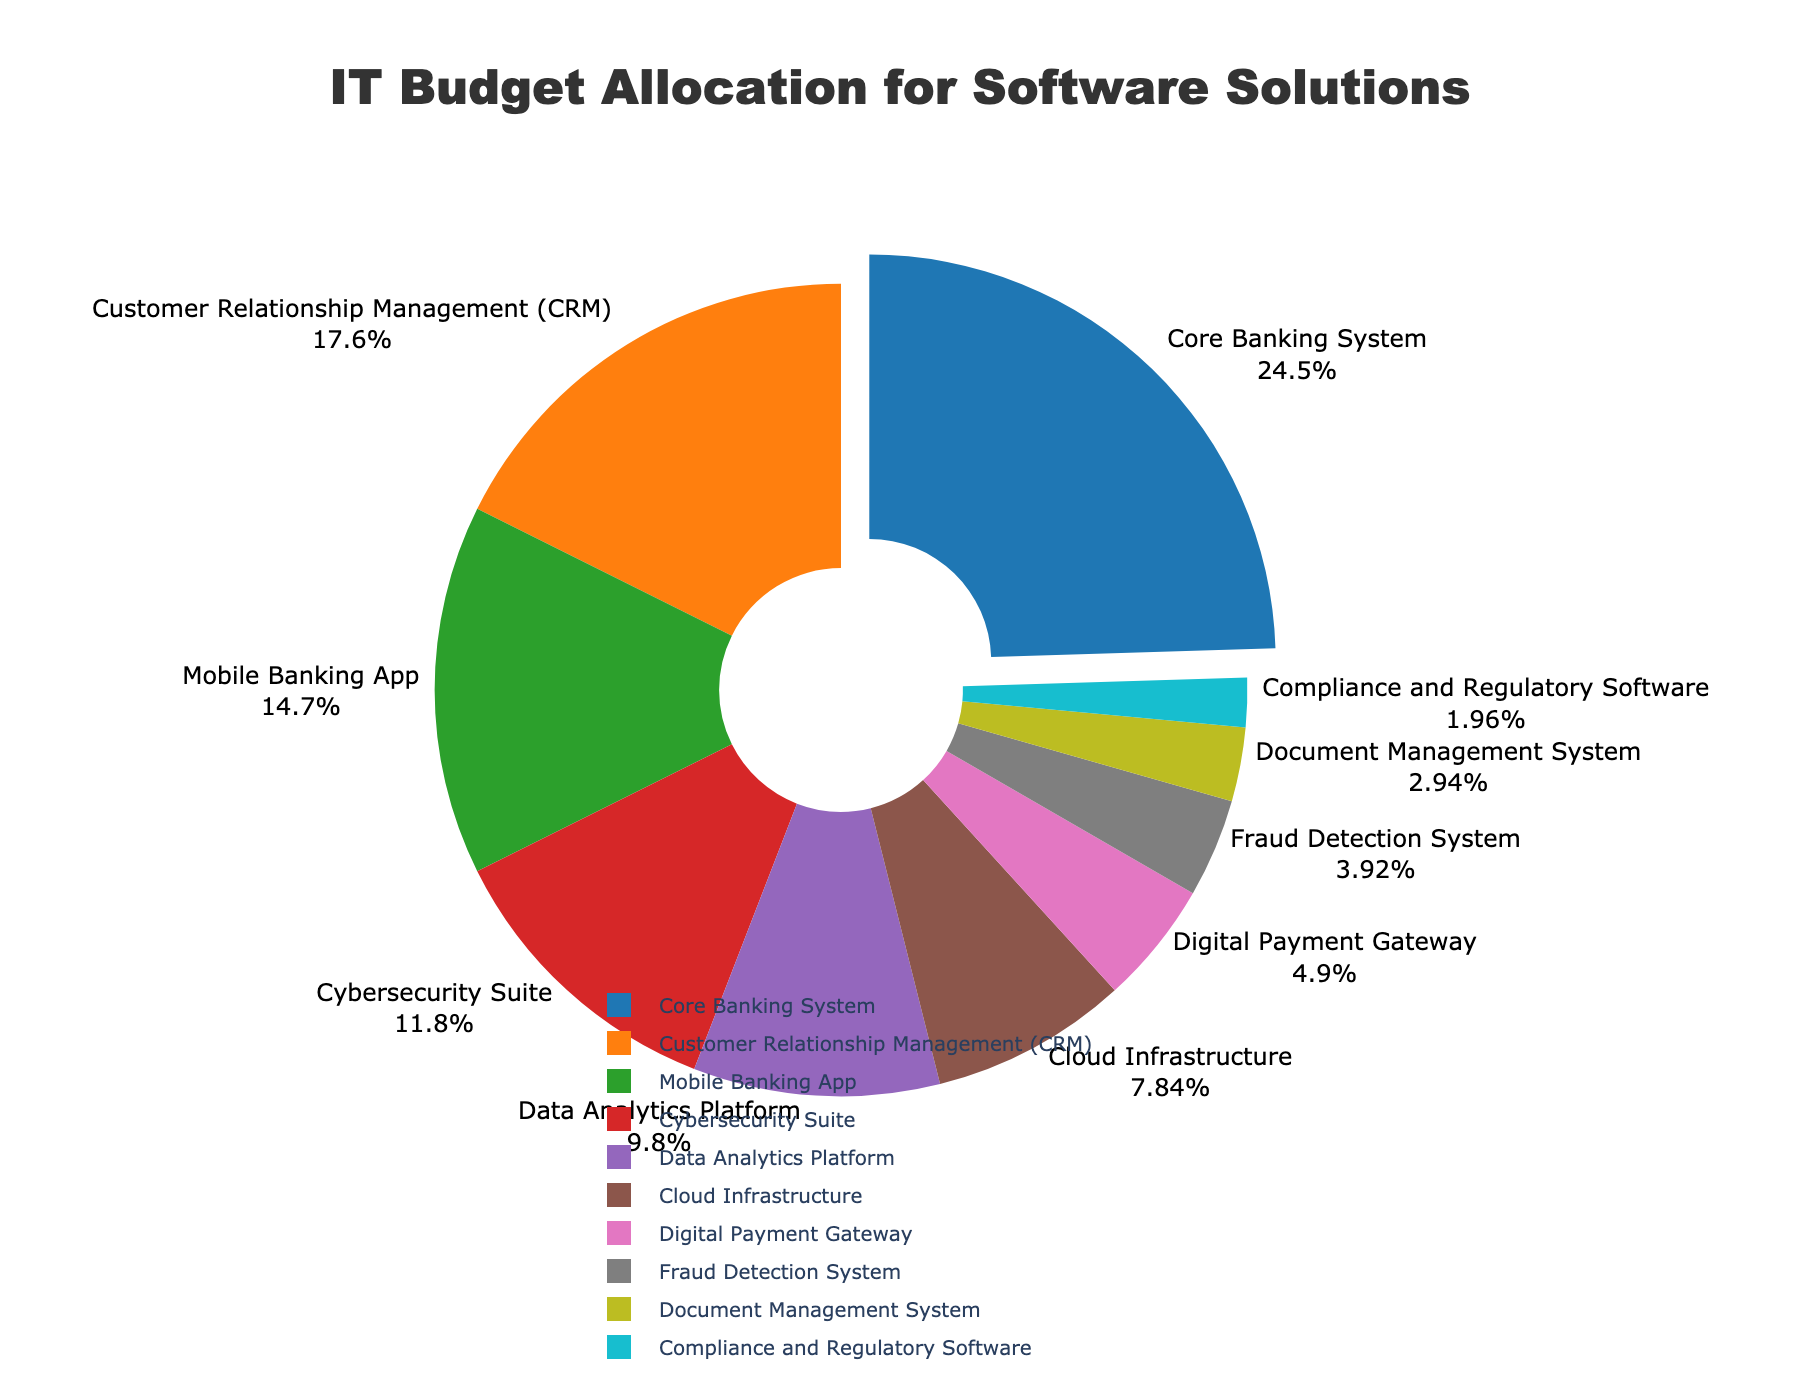What software solution has the highest budget allocation? The slice that is pulled out in the pie chart represents the software solution with the highest budget allocation. The 'Core Banking System' slice stands out.
Answer: Core Banking System What is the total budget allocation for the Mobile Banking App and Cybersecurity Suite? To find the total allocation, add the percentages for the Mobile Banking App (15%) and Cybersecurity Suite (12%): 15% + 12% = 27%.
Answer: 27% Which software solutions have a budget allocation less than 5%? Examine the chart for slices representing less than 5% of the budget. These slices are: Fraud Detection System (4%), Document Management System (3%), Compliance and Regulatory Software (2%).
Answer: Fraud Detection System, Document Management System, Compliance and Regulatory Software How does the budget allocation for the Digital Payment Gateway compare to the Data Analytics Platform? The pie chart shows the Digital Payment Gateway with 5% and the Data Analytics Platform with 10%, meaning the Data Analytics Platform has double the allocation of the Digital Payment Gateway.
Answer: Data Analytics Platform is double What is the combined budget allocation for software solutions related to customer service (CRM and Mobile Banking App)? Add the percentages for Customer Relationship Management (CRM) (18%) and Mobile Banking App (15%): 18% + 15% = 33%.
Answer: 33% Which software solution is represented with a green slice in the pie chart? The green color slice in the pie chart identifies the Cybersecurity Suite.
Answer: Cybersecurity Suite If the bank wants to increase the Digital Payment Gateway budget allocation by 50%, what would be its new budget percentage? The current allocation for Digital Payment Gateway is 5%. Increasing it by 50%: 5% * 50% = 2.5%. Adding this to the current allocation: 5% + 2.5% = 7.5%.
Answer: 7.5% By how much does the Cloud Infrastructure budget allocation exceed the Fraud Detection System? Subtract the allocation of Fraud Detection System (4%) from Cloud Infrastructure (8%): 8% - 4% = 4%.
Answer: 4% What's the average budget allocation for the Core Banking System, CRM, and Mobile Banking App? Sum the values for Core Banking System (25%), CRM (18%), and Mobile Banking App (15%) and then divide by the number of solutions: (25% + 18% + 15%) / 3 = 58% / 3 = 19.33%.
Answer: 19.33% 